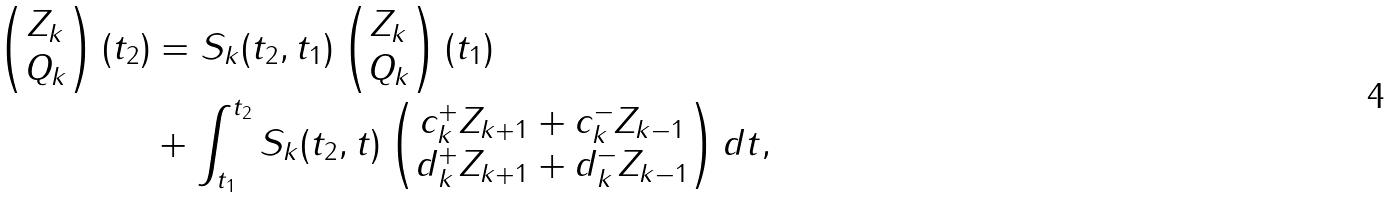Convert formula to latex. <formula><loc_0><loc_0><loc_500><loc_500>\begin{pmatrix} Z _ { k } \\ Q _ { k } \end{pmatrix} ( t _ { 2 } ) & = S _ { k } ( t _ { 2 } , t _ { 1 } ) \begin{pmatrix} Z _ { k } \\ Q _ { k } \end{pmatrix} ( t _ { 1 } ) \\ & + \int _ { t _ { 1 } } ^ { t _ { 2 } } S _ { k } ( t _ { 2 } , t ) \begin{pmatrix} c _ { k } ^ { + } Z _ { k + 1 } + c _ { k } ^ { - } Z _ { k - 1 } \\ d _ { k } ^ { + } Z _ { k + 1 } + d _ { k } ^ { - } Z _ { k - 1 } \end{pmatrix} d t ,</formula> 